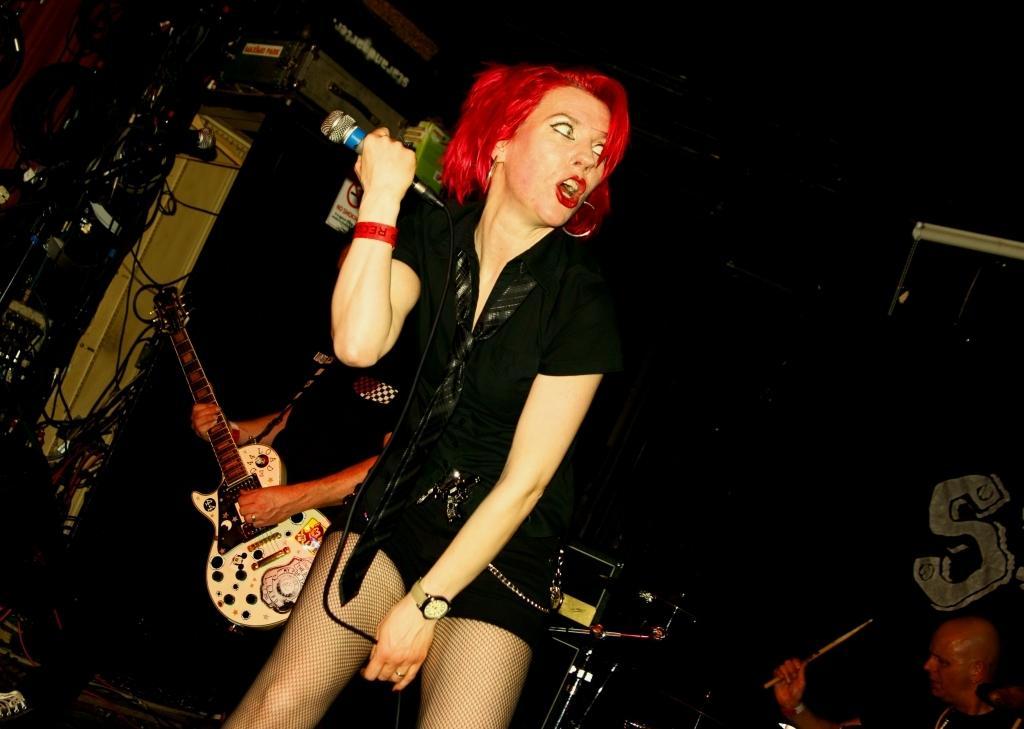Please provide a concise description of this image. In this picture we can see one women standing and holding a mike in her hand and she is giving aww expression on her face. We can see persons on the platform playing musical instruments. Background is dark. 